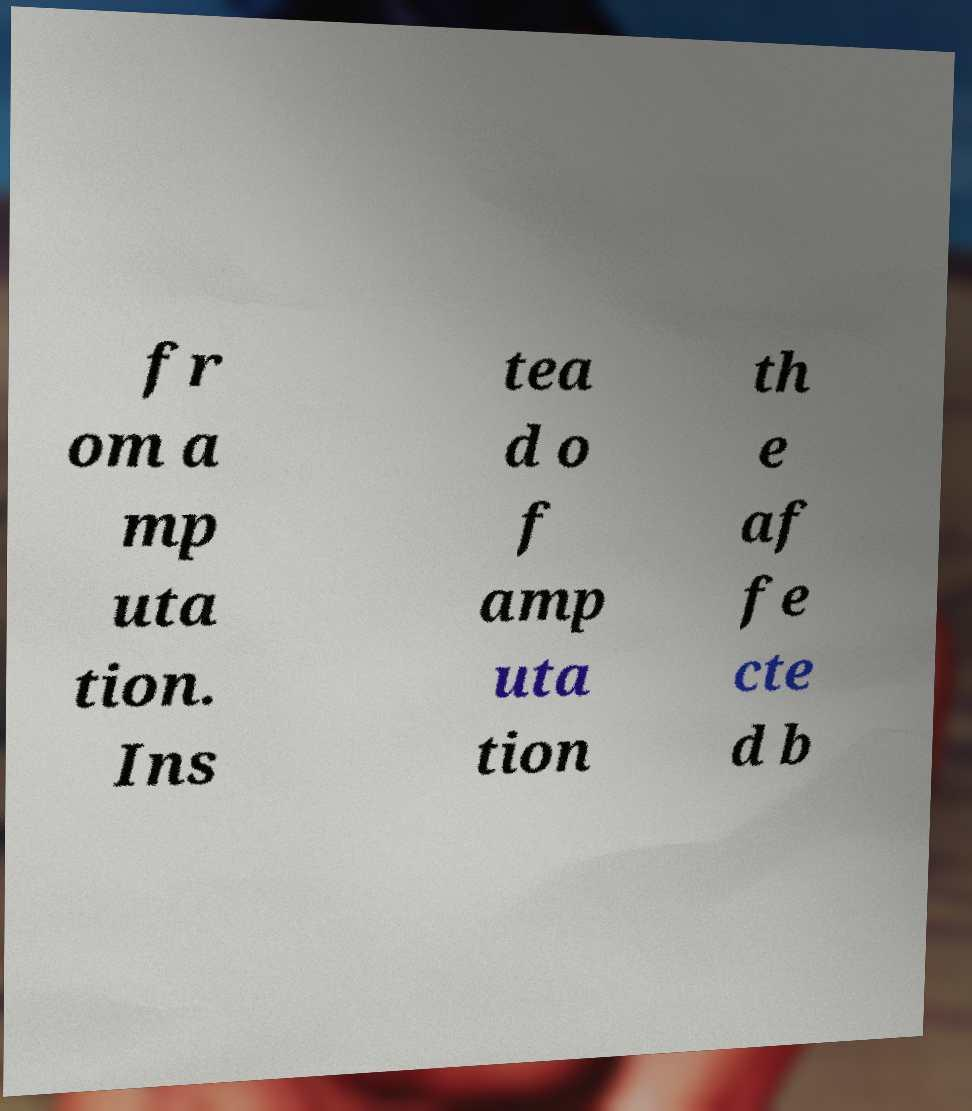Can you accurately transcribe the text from the provided image for me? fr om a mp uta tion. Ins tea d o f amp uta tion th e af fe cte d b 